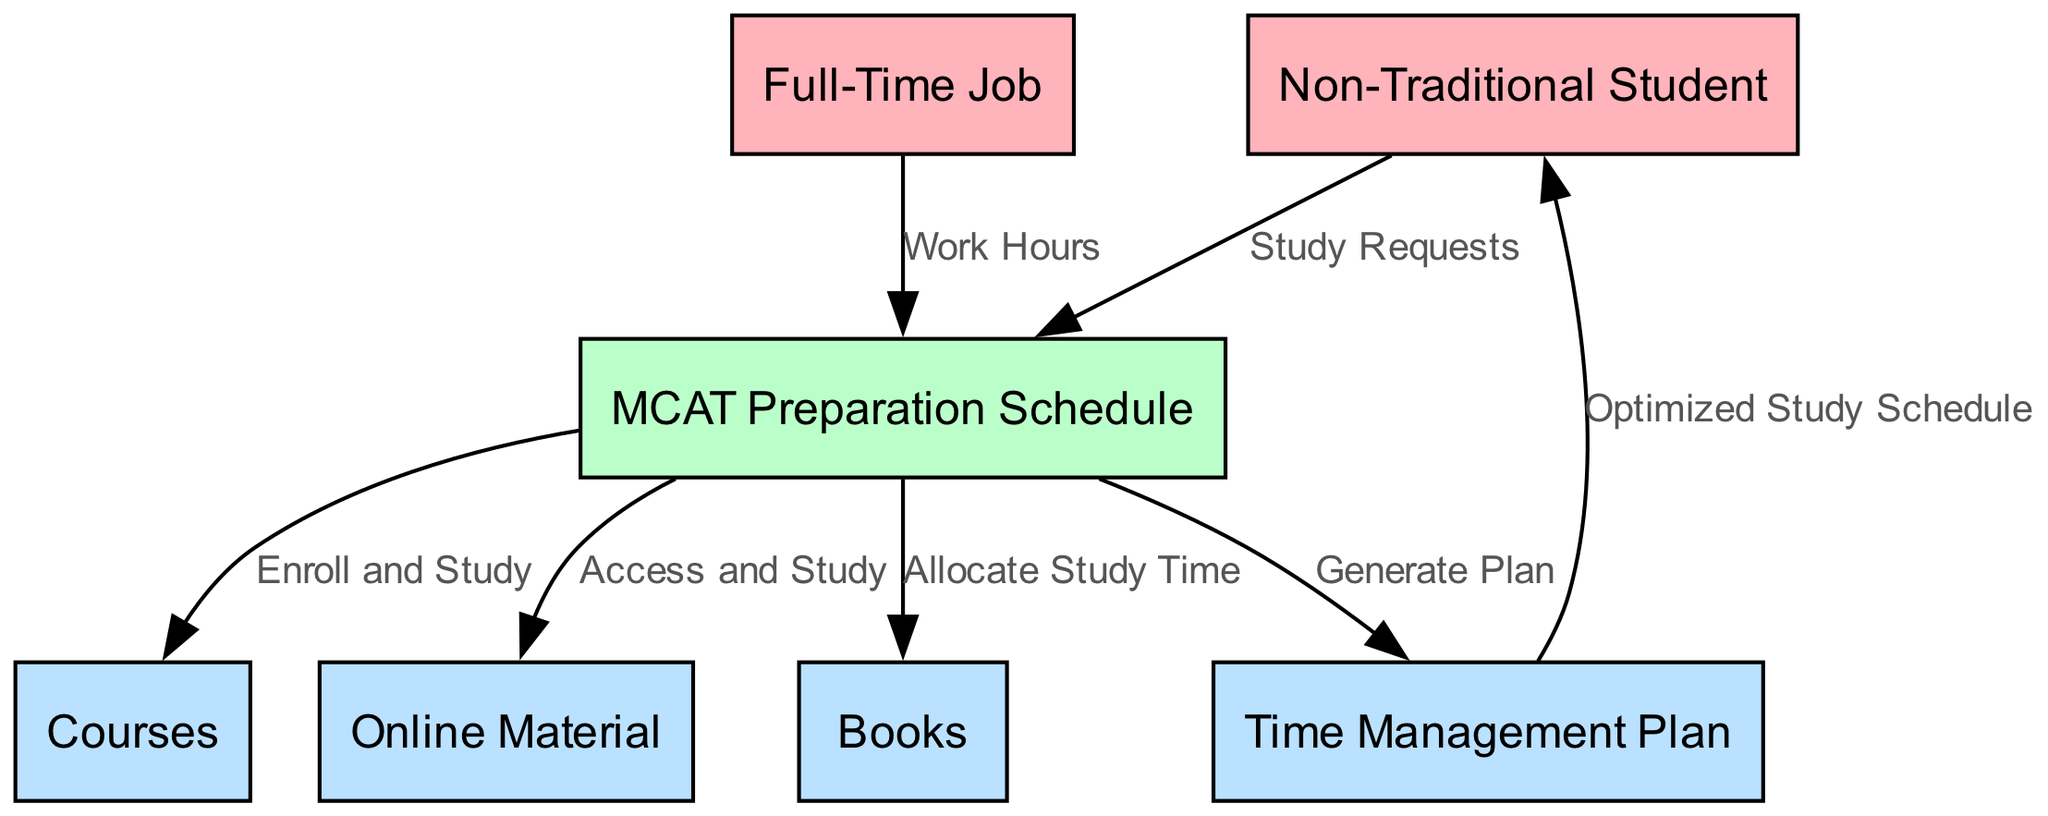What is the external entity that initiates study requests? The external entity that initiates study requests as depicted in the diagram is the "Non-Traditional Student", as indicated by the flow directed from this entity to the "MCAT Preparation Schedule".
Answer: Non-Traditional Student How many data stores are present in the diagram? The diagram includes four data stores: "Books", "Courses", "Online Material", and "Time Management Plan". These can be counted from the entities listed in the diagram, which are categorized as data stores.
Answer: 4 What data flows from the MCAT Preparation Schedule to the Books? The data that flows from the "MCAT Preparation Schedule" to the "Books" is "Allocate Study Time", as indicated by the direct connection in the data flow diagram.
Answer: Allocate Study Time Which entity provides work hours to the MCAT Preparation Schedule? The "Full-Time Job" entity provides the work hours to the "MCAT Preparation Schedule", which is clearly shown by the directed flow between these two entities in the diagram.
Answer: Full-Time Job What process generates an optimized study schedule for the Non-Traditional Student? The "MCAT Preparation Schedule" process generates an optimized study schedule by producing a flow labeled "Generate Plan" directed towards the "Time Management Plan", which then flows to the "Non-Traditional Student".
Answer: MCAT Preparation Schedule How many edges are connecting the process entity to data stores? There are three edges connecting the "MCAT Preparation Schedule" process to the data store entities: one to "Books", one to "Courses", and one to "Online Material". These are specifically noted by the flows directed towards each data store.
Answer: 3 What type of items are included as data flows from the MCAT Preparation Schedule? The MCAT Preparation Schedule produces data flows that include "Allocate Study Time", "Enroll and Study", "Access and Study", and "Generate Plan", showing the various actions directed towards different data stores and planning outputs.
Answer: Four What is the flow that connects the Time Management Plan back to the Non-Traditional Student? The flow connecting the "Time Management Plan" back to the "Non-Traditional Student" is labeled "Optimized Study Schedule". This indicates the output of the planning process directed at the student.
Answer: Optimized Study Schedule 